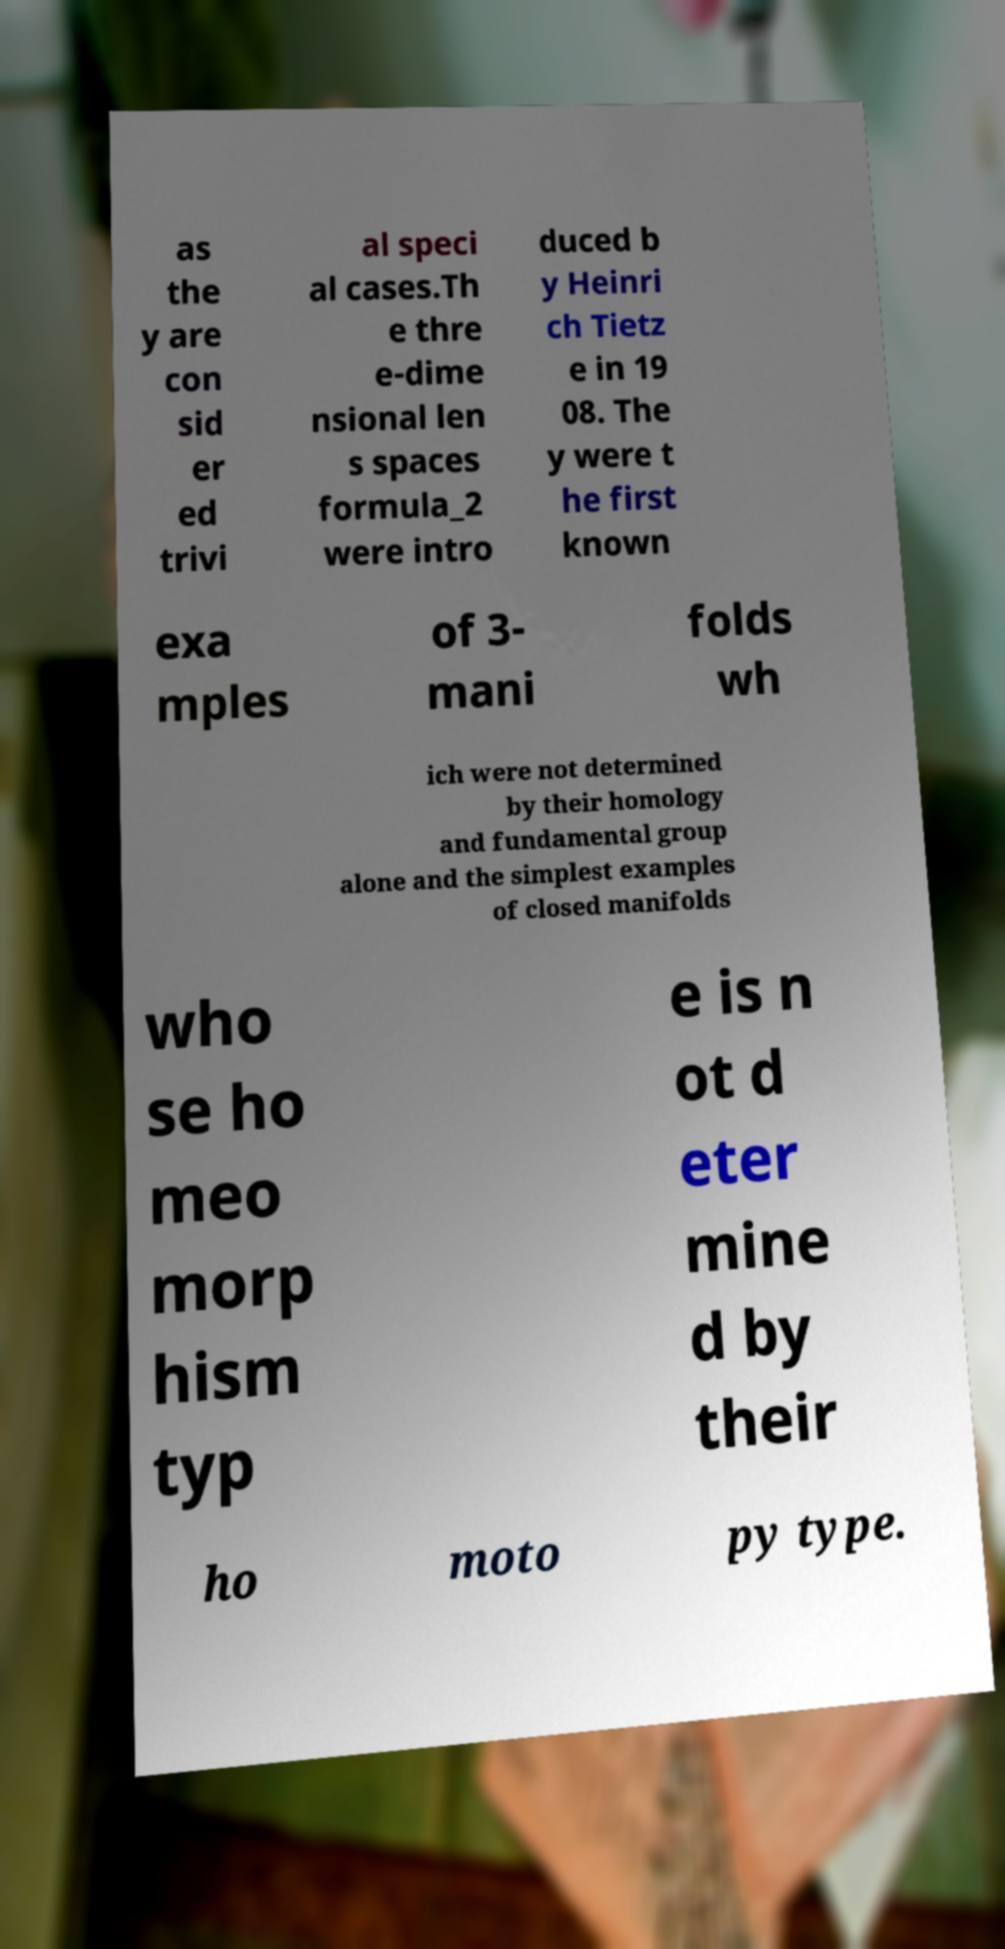Can you read and provide the text displayed in the image?This photo seems to have some interesting text. Can you extract and type it out for me? as the y are con sid er ed trivi al speci al cases.Th e thre e-dime nsional len s spaces formula_2 were intro duced b y Heinri ch Tietz e in 19 08. The y were t he first known exa mples of 3- mani folds wh ich were not determined by their homology and fundamental group alone and the simplest examples of closed manifolds who se ho meo morp hism typ e is n ot d eter mine d by their ho moto py type. 